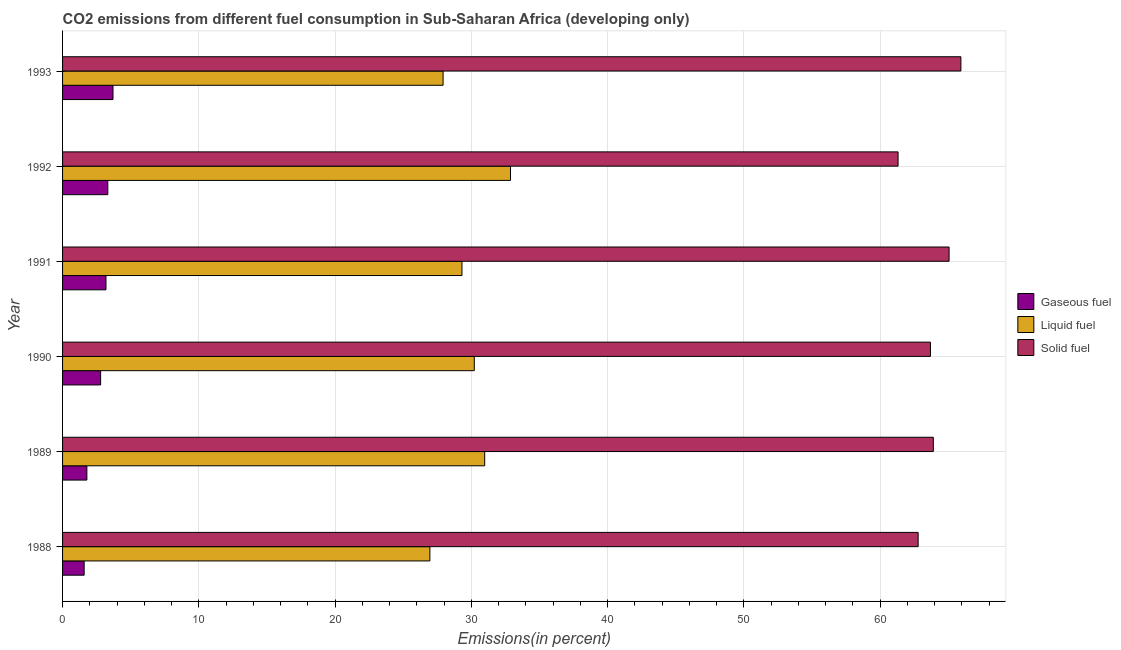How many different coloured bars are there?
Offer a terse response. 3. How many groups of bars are there?
Ensure brevity in your answer.  6. Are the number of bars per tick equal to the number of legend labels?
Your answer should be compact. Yes. How many bars are there on the 5th tick from the top?
Offer a terse response. 3. What is the label of the 6th group of bars from the top?
Offer a very short reply. 1988. In how many cases, is the number of bars for a given year not equal to the number of legend labels?
Provide a succinct answer. 0. What is the percentage of liquid fuel emission in 1992?
Make the answer very short. 32.87. Across all years, what is the maximum percentage of liquid fuel emission?
Your response must be concise. 32.87. Across all years, what is the minimum percentage of solid fuel emission?
Give a very brief answer. 61.31. In which year was the percentage of solid fuel emission maximum?
Make the answer very short. 1993. In which year was the percentage of solid fuel emission minimum?
Offer a terse response. 1992. What is the total percentage of liquid fuel emission in the graph?
Provide a succinct answer. 178.25. What is the difference between the percentage of gaseous fuel emission in 1989 and that in 1990?
Keep it short and to the point. -1.01. What is the difference between the percentage of liquid fuel emission in 1991 and the percentage of gaseous fuel emission in 1993?
Your answer should be compact. 25.61. What is the average percentage of liquid fuel emission per year?
Your answer should be compact. 29.71. In the year 1992, what is the difference between the percentage of solid fuel emission and percentage of liquid fuel emission?
Your answer should be compact. 28.44. In how many years, is the percentage of solid fuel emission greater than 38 %?
Make the answer very short. 6. What is the ratio of the percentage of gaseous fuel emission in 1990 to that in 1991?
Keep it short and to the point. 0.88. What is the difference between the highest and the second highest percentage of gaseous fuel emission?
Ensure brevity in your answer.  0.38. What is the difference between the highest and the lowest percentage of liquid fuel emission?
Your answer should be compact. 5.92. Is the sum of the percentage of liquid fuel emission in 1989 and 1993 greater than the maximum percentage of solid fuel emission across all years?
Give a very brief answer. No. What does the 2nd bar from the top in 1991 represents?
Give a very brief answer. Liquid fuel. What does the 2nd bar from the bottom in 1991 represents?
Provide a succinct answer. Liquid fuel. Is it the case that in every year, the sum of the percentage of gaseous fuel emission and percentage of liquid fuel emission is greater than the percentage of solid fuel emission?
Keep it short and to the point. No. Are all the bars in the graph horizontal?
Provide a short and direct response. Yes. What is the difference between two consecutive major ticks on the X-axis?
Provide a short and direct response. 10. Does the graph contain any zero values?
Make the answer very short. No. Does the graph contain grids?
Keep it short and to the point. Yes. Where does the legend appear in the graph?
Your answer should be very brief. Center right. How many legend labels are there?
Offer a terse response. 3. How are the legend labels stacked?
Your answer should be compact. Vertical. What is the title of the graph?
Ensure brevity in your answer.  CO2 emissions from different fuel consumption in Sub-Saharan Africa (developing only). What is the label or title of the X-axis?
Offer a very short reply. Emissions(in percent). What is the label or title of the Y-axis?
Provide a short and direct response. Year. What is the Emissions(in percent) of Gaseous fuel in 1988?
Offer a very short reply. 1.58. What is the Emissions(in percent) in Liquid fuel in 1988?
Give a very brief answer. 26.96. What is the Emissions(in percent) of Solid fuel in 1988?
Give a very brief answer. 62.78. What is the Emissions(in percent) of Gaseous fuel in 1989?
Ensure brevity in your answer.  1.78. What is the Emissions(in percent) in Liquid fuel in 1989?
Keep it short and to the point. 30.98. What is the Emissions(in percent) of Solid fuel in 1989?
Your response must be concise. 63.9. What is the Emissions(in percent) of Gaseous fuel in 1990?
Provide a short and direct response. 2.79. What is the Emissions(in percent) of Liquid fuel in 1990?
Offer a terse response. 30.21. What is the Emissions(in percent) in Solid fuel in 1990?
Keep it short and to the point. 63.69. What is the Emissions(in percent) of Gaseous fuel in 1991?
Give a very brief answer. 3.19. What is the Emissions(in percent) in Liquid fuel in 1991?
Offer a very short reply. 29.31. What is the Emissions(in percent) in Solid fuel in 1991?
Make the answer very short. 65.05. What is the Emissions(in percent) of Gaseous fuel in 1992?
Your answer should be very brief. 3.32. What is the Emissions(in percent) in Liquid fuel in 1992?
Your answer should be compact. 32.87. What is the Emissions(in percent) of Solid fuel in 1992?
Keep it short and to the point. 61.31. What is the Emissions(in percent) of Gaseous fuel in 1993?
Give a very brief answer. 3.7. What is the Emissions(in percent) of Liquid fuel in 1993?
Your answer should be very brief. 27.92. What is the Emissions(in percent) of Solid fuel in 1993?
Give a very brief answer. 65.92. Across all years, what is the maximum Emissions(in percent) of Gaseous fuel?
Ensure brevity in your answer.  3.7. Across all years, what is the maximum Emissions(in percent) of Liquid fuel?
Keep it short and to the point. 32.87. Across all years, what is the maximum Emissions(in percent) of Solid fuel?
Give a very brief answer. 65.92. Across all years, what is the minimum Emissions(in percent) in Gaseous fuel?
Your answer should be compact. 1.58. Across all years, what is the minimum Emissions(in percent) of Liquid fuel?
Your response must be concise. 26.96. Across all years, what is the minimum Emissions(in percent) in Solid fuel?
Your answer should be very brief. 61.31. What is the total Emissions(in percent) in Gaseous fuel in the graph?
Your answer should be compact. 16.37. What is the total Emissions(in percent) in Liquid fuel in the graph?
Provide a short and direct response. 178.25. What is the total Emissions(in percent) in Solid fuel in the graph?
Your answer should be very brief. 382.66. What is the difference between the Emissions(in percent) of Gaseous fuel in 1988 and that in 1989?
Provide a short and direct response. -0.2. What is the difference between the Emissions(in percent) in Liquid fuel in 1988 and that in 1989?
Give a very brief answer. -4.02. What is the difference between the Emissions(in percent) in Solid fuel in 1988 and that in 1989?
Make the answer very short. -1.11. What is the difference between the Emissions(in percent) in Gaseous fuel in 1988 and that in 1990?
Offer a terse response. -1.21. What is the difference between the Emissions(in percent) in Liquid fuel in 1988 and that in 1990?
Offer a very short reply. -3.26. What is the difference between the Emissions(in percent) in Solid fuel in 1988 and that in 1990?
Your response must be concise. -0.9. What is the difference between the Emissions(in percent) in Gaseous fuel in 1988 and that in 1991?
Your answer should be very brief. -1.6. What is the difference between the Emissions(in percent) in Liquid fuel in 1988 and that in 1991?
Provide a short and direct response. -2.35. What is the difference between the Emissions(in percent) in Solid fuel in 1988 and that in 1991?
Offer a terse response. -2.27. What is the difference between the Emissions(in percent) of Gaseous fuel in 1988 and that in 1992?
Offer a terse response. -1.74. What is the difference between the Emissions(in percent) in Liquid fuel in 1988 and that in 1992?
Offer a terse response. -5.92. What is the difference between the Emissions(in percent) in Solid fuel in 1988 and that in 1992?
Your answer should be compact. 1.47. What is the difference between the Emissions(in percent) of Gaseous fuel in 1988 and that in 1993?
Your answer should be very brief. -2.12. What is the difference between the Emissions(in percent) of Liquid fuel in 1988 and that in 1993?
Keep it short and to the point. -0.97. What is the difference between the Emissions(in percent) in Solid fuel in 1988 and that in 1993?
Provide a succinct answer. -3.14. What is the difference between the Emissions(in percent) of Gaseous fuel in 1989 and that in 1990?
Offer a terse response. -1.01. What is the difference between the Emissions(in percent) in Liquid fuel in 1989 and that in 1990?
Your answer should be compact. 0.76. What is the difference between the Emissions(in percent) in Solid fuel in 1989 and that in 1990?
Offer a very short reply. 0.21. What is the difference between the Emissions(in percent) in Gaseous fuel in 1989 and that in 1991?
Give a very brief answer. -1.4. What is the difference between the Emissions(in percent) in Liquid fuel in 1989 and that in 1991?
Offer a terse response. 1.67. What is the difference between the Emissions(in percent) in Solid fuel in 1989 and that in 1991?
Provide a short and direct response. -1.16. What is the difference between the Emissions(in percent) in Gaseous fuel in 1989 and that in 1992?
Offer a very short reply. -1.54. What is the difference between the Emissions(in percent) in Liquid fuel in 1989 and that in 1992?
Your answer should be very brief. -1.89. What is the difference between the Emissions(in percent) in Solid fuel in 1989 and that in 1992?
Make the answer very short. 2.59. What is the difference between the Emissions(in percent) in Gaseous fuel in 1989 and that in 1993?
Keep it short and to the point. -1.92. What is the difference between the Emissions(in percent) of Liquid fuel in 1989 and that in 1993?
Make the answer very short. 3.05. What is the difference between the Emissions(in percent) of Solid fuel in 1989 and that in 1993?
Provide a succinct answer. -2.02. What is the difference between the Emissions(in percent) of Gaseous fuel in 1990 and that in 1991?
Provide a short and direct response. -0.39. What is the difference between the Emissions(in percent) in Liquid fuel in 1990 and that in 1991?
Your answer should be compact. 0.9. What is the difference between the Emissions(in percent) of Solid fuel in 1990 and that in 1991?
Offer a very short reply. -1.37. What is the difference between the Emissions(in percent) of Gaseous fuel in 1990 and that in 1992?
Make the answer very short. -0.53. What is the difference between the Emissions(in percent) of Liquid fuel in 1990 and that in 1992?
Provide a succinct answer. -2.66. What is the difference between the Emissions(in percent) of Solid fuel in 1990 and that in 1992?
Offer a very short reply. 2.38. What is the difference between the Emissions(in percent) in Gaseous fuel in 1990 and that in 1993?
Offer a very short reply. -0.91. What is the difference between the Emissions(in percent) in Liquid fuel in 1990 and that in 1993?
Keep it short and to the point. 2.29. What is the difference between the Emissions(in percent) of Solid fuel in 1990 and that in 1993?
Offer a terse response. -2.23. What is the difference between the Emissions(in percent) in Gaseous fuel in 1991 and that in 1992?
Give a very brief answer. -0.13. What is the difference between the Emissions(in percent) of Liquid fuel in 1991 and that in 1992?
Provide a short and direct response. -3.56. What is the difference between the Emissions(in percent) in Solid fuel in 1991 and that in 1992?
Give a very brief answer. 3.74. What is the difference between the Emissions(in percent) of Gaseous fuel in 1991 and that in 1993?
Your response must be concise. -0.51. What is the difference between the Emissions(in percent) of Liquid fuel in 1991 and that in 1993?
Provide a succinct answer. 1.39. What is the difference between the Emissions(in percent) of Solid fuel in 1991 and that in 1993?
Provide a succinct answer. -0.87. What is the difference between the Emissions(in percent) of Gaseous fuel in 1992 and that in 1993?
Offer a very short reply. -0.38. What is the difference between the Emissions(in percent) in Liquid fuel in 1992 and that in 1993?
Your answer should be compact. 4.95. What is the difference between the Emissions(in percent) in Solid fuel in 1992 and that in 1993?
Give a very brief answer. -4.61. What is the difference between the Emissions(in percent) in Gaseous fuel in 1988 and the Emissions(in percent) in Liquid fuel in 1989?
Make the answer very short. -29.39. What is the difference between the Emissions(in percent) in Gaseous fuel in 1988 and the Emissions(in percent) in Solid fuel in 1989?
Your response must be concise. -62.32. What is the difference between the Emissions(in percent) of Liquid fuel in 1988 and the Emissions(in percent) of Solid fuel in 1989?
Your answer should be very brief. -36.94. What is the difference between the Emissions(in percent) of Gaseous fuel in 1988 and the Emissions(in percent) of Liquid fuel in 1990?
Keep it short and to the point. -28.63. What is the difference between the Emissions(in percent) of Gaseous fuel in 1988 and the Emissions(in percent) of Solid fuel in 1990?
Provide a short and direct response. -62.1. What is the difference between the Emissions(in percent) in Liquid fuel in 1988 and the Emissions(in percent) in Solid fuel in 1990?
Make the answer very short. -36.73. What is the difference between the Emissions(in percent) in Gaseous fuel in 1988 and the Emissions(in percent) in Liquid fuel in 1991?
Keep it short and to the point. -27.73. What is the difference between the Emissions(in percent) of Gaseous fuel in 1988 and the Emissions(in percent) of Solid fuel in 1991?
Give a very brief answer. -63.47. What is the difference between the Emissions(in percent) in Liquid fuel in 1988 and the Emissions(in percent) in Solid fuel in 1991?
Make the answer very short. -38.1. What is the difference between the Emissions(in percent) in Gaseous fuel in 1988 and the Emissions(in percent) in Liquid fuel in 1992?
Your response must be concise. -31.29. What is the difference between the Emissions(in percent) of Gaseous fuel in 1988 and the Emissions(in percent) of Solid fuel in 1992?
Offer a terse response. -59.73. What is the difference between the Emissions(in percent) in Liquid fuel in 1988 and the Emissions(in percent) in Solid fuel in 1992?
Provide a succinct answer. -34.36. What is the difference between the Emissions(in percent) of Gaseous fuel in 1988 and the Emissions(in percent) of Liquid fuel in 1993?
Offer a very short reply. -26.34. What is the difference between the Emissions(in percent) of Gaseous fuel in 1988 and the Emissions(in percent) of Solid fuel in 1993?
Give a very brief answer. -64.34. What is the difference between the Emissions(in percent) of Liquid fuel in 1988 and the Emissions(in percent) of Solid fuel in 1993?
Keep it short and to the point. -38.97. What is the difference between the Emissions(in percent) in Gaseous fuel in 1989 and the Emissions(in percent) in Liquid fuel in 1990?
Keep it short and to the point. -28.43. What is the difference between the Emissions(in percent) in Gaseous fuel in 1989 and the Emissions(in percent) in Solid fuel in 1990?
Provide a short and direct response. -61.91. What is the difference between the Emissions(in percent) in Liquid fuel in 1989 and the Emissions(in percent) in Solid fuel in 1990?
Ensure brevity in your answer.  -32.71. What is the difference between the Emissions(in percent) of Gaseous fuel in 1989 and the Emissions(in percent) of Liquid fuel in 1991?
Your answer should be compact. -27.53. What is the difference between the Emissions(in percent) of Gaseous fuel in 1989 and the Emissions(in percent) of Solid fuel in 1991?
Ensure brevity in your answer.  -63.27. What is the difference between the Emissions(in percent) in Liquid fuel in 1989 and the Emissions(in percent) in Solid fuel in 1991?
Keep it short and to the point. -34.08. What is the difference between the Emissions(in percent) in Gaseous fuel in 1989 and the Emissions(in percent) in Liquid fuel in 1992?
Make the answer very short. -31.09. What is the difference between the Emissions(in percent) of Gaseous fuel in 1989 and the Emissions(in percent) of Solid fuel in 1992?
Make the answer very short. -59.53. What is the difference between the Emissions(in percent) of Liquid fuel in 1989 and the Emissions(in percent) of Solid fuel in 1992?
Your answer should be compact. -30.33. What is the difference between the Emissions(in percent) of Gaseous fuel in 1989 and the Emissions(in percent) of Liquid fuel in 1993?
Your response must be concise. -26.14. What is the difference between the Emissions(in percent) of Gaseous fuel in 1989 and the Emissions(in percent) of Solid fuel in 1993?
Your answer should be very brief. -64.14. What is the difference between the Emissions(in percent) of Liquid fuel in 1989 and the Emissions(in percent) of Solid fuel in 1993?
Offer a terse response. -34.95. What is the difference between the Emissions(in percent) in Gaseous fuel in 1990 and the Emissions(in percent) in Liquid fuel in 1991?
Offer a terse response. -26.52. What is the difference between the Emissions(in percent) of Gaseous fuel in 1990 and the Emissions(in percent) of Solid fuel in 1991?
Provide a short and direct response. -62.26. What is the difference between the Emissions(in percent) in Liquid fuel in 1990 and the Emissions(in percent) in Solid fuel in 1991?
Provide a succinct answer. -34.84. What is the difference between the Emissions(in percent) of Gaseous fuel in 1990 and the Emissions(in percent) of Liquid fuel in 1992?
Your answer should be compact. -30.08. What is the difference between the Emissions(in percent) in Gaseous fuel in 1990 and the Emissions(in percent) in Solid fuel in 1992?
Keep it short and to the point. -58.52. What is the difference between the Emissions(in percent) of Liquid fuel in 1990 and the Emissions(in percent) of Solid fuel in 1992?
Offer a terse response. -31.1. What is the difference between the Emissions(in percent) of Gaseous fuel in 1990 and the Emissions(in percent) of Liquid fuel in 1993?
Keep it short and to the point. -25.13. What is the difference between the Emissions(in percent) of Gaseous fuel in 1990 and the Emissions(in percent) of Solid fuel in 1993?
Provide a short and direct response. -63.13. What is the difference between the Emissions(in percent) in Liquid fuel in 1990 and the Emissions(in percent) in Solid fuel in 1993?
Offer a very short reply. -35.71. What is the difference between the Emissions(in percent) in Gaseous fuel in 1991 and the Emissions(in percent) in Liquid fuel in 1992?
Provide a short and direct response. -29.68. What is the difference between the Emissions(in percent) in Gaseous fuel in 1991 and the Emissions(in percent) in Solid fuel in 1992?
Give a very brief answer. -58.13. What is the difference between the Emissions(in percent) of Liquid fuel in 1991 and the Emissions(in percent) of Solid fuel in 1992?
Keep it short and to the point. -32. What is the difference between the Emissions(in percent) of Gaseous fuel in 1991 and the Emissions(in percent) of Liquid fuel in 1993?
Keep it short and to the point. -24.74. What is the difference between the Emissions(in percent) of Gaseous fuel in 1991 and the Emissions(in percent) of Solid fuel in 1993?
Your answer should be very brief. -62.74. What is the difference between the Emissions(in percent) of Liquid fuel in 1991 and the Emissions(in percent) of Solid fuel in 1993?
Offer a very short reply. -36.61. What is the difference between the Emissions(in percent) in Gaseous fuel in 1992 and the Emissions(in percent) in Liquid fuel in 1993?
Offer a very short reply. -24.6. What is the difference between the Emissions(in percent) in Gaseous fuel in 1992 and the Emissions(in percent) in Solid fuel in 1993?
Ensure brevity in your answer.  -62.6. What is the difference between the Emissions(in percent) of Liquid fuel in 1992 and the Emissions(in percent) of Solid fuel in 1993?
Your answer should be compact. -33.05. What is the average Emissions(in percent) in Gaseous fuel per year?
Your response must be concise. 2.73. What is the average Emissions(in percent) in Liquid fuel per year?
Ensure brevity in your answer.  29.71. What is the average Emissions(in percent) of Solid fuel per year?
Offer a very short reply. 63.78. In the year 1988, what is the difference between the Emissions(in percent) of Gaseous fuel and Emissions(in percent) of Liquid fuel?
Make the answer very short. -25.37. In the year 1988, what is the difference between the Emissions(in percent) in Gaseous fuel and Emissions(in percent) in Solid fuel?
Your answer should be compact. -61.2. In the year 1988, what is the difference between the Emissions(in percent) of Liquid fuel and Emissions(in percent) of Solid fuel?
Your answer should be very brief. -35.83. In the year 1989, what is the difference between the Emissions(in percent) in Gaseous fuel and Emissions(in percent) in Liquid fuel?
Provide a succinct answer. -29.19. In the year 1989, what is the difference between the Emissions(in percent) in Gaseous fuel and Emissions(in percent) in Solid fuel?
Offer a terse response. -62.12. In the year 1989, what is the difference between the Emissions(in percent) in Liquid fuel and Emissions(in percent) in Solid fuel?
Provide a succinct answer. -32.92. In the year 1990, what is the difference between the Emissions(in percent) in Gaseous fuel and Emissions(in percent) in Liquid fuel?
Your answer should be very brief. -27.42. In the year 1990, what is the difference between the Emissions(in percent) of Gaseous fuel and Emissions(in percent) of Solid fuel?
Your answer should be very brief. -60.9. In the year 1990, what is the difference between the Emissions(in percent) of Liquid fuel and Emissions(in percent) of Solid fuel?
Keep it short and to the point. -33.47. In the year 1991, what is the difference between the Emissions(in percent) in Gaseous fuel and Emissions(in percent) in Liquid fuel?
Offer a terse response. -26.12. In the year 1991, what is the difference between the Emissions(in percent) in Gaseous fuel and Emissions(in percent) in Solid fuel?
Make the answer very short. -61.87. In the year 1991, what is the difference between the Emissions(in percent) of Liquid fuel and Emissions(in percent) of Solid fuel?
Your response must be concise. -35.75. In the year 1992, what is the difference between the Emissions(in percent) of Gaseous fuel and Emissions(in percent) of Liquid fuel?
Offer a terse response. -29.55. In the year 1992, what is the difference between the Emissions(in percent) in Gaseous fuel and Emissions(in percent) in Solid fuel?
Provide a succinct answer. -57.99. In the year 1992, what is the difference between the Emissions(in percent) of Liquid fuel and Emissions(in percent) of Solid fuel?
Give a very brief answer. -28.44. In the year 1993, what is the difference between the Emissions(in percent) in Gaseous fuel and Emissions(in percent) in Liquid fuel?
Your answer should be very brief. -24.22. In the year 1993, what is the difference between the Emissions(in percent) in Gaseous fuel and Emissions(in percent) in Solid fuel?
Give a very brief answer. -62.22. In the year 1993, what is the difference between the Emissions(in percent) in Liquid fuel and Emissions(in percent) in Solid fuel?
Provide a short and direct response. -38. What is the ratio of the Emissions(in percent) of Gaseous fuel in 1988 to that in 1989?
Offer a very short reply. 0.89. What is the ratio of the Emissions(in percent) of Liquid fuel in 1988 to that in 1989?
Your answer should be very brief. 0.87. What is the ratio of the Emissions(in percent) in Solid fuel in 1988 to that in 1989?
Provide a short and direct response. 0.98. What is the ratio of the Emissions(in percent) of Gaseous fuel in 1988 to that in 1990?
Offer a terse response. 0.57. What is the ratio of the Emissions(in percent) in Liquid fuel in 1988 to that in 1990?
Give a very brief answer. 0.89. What is the ratio of the Emissions(in percent) in Solid fuel in 1988 to that in 1990?
Your answer should be compact. 0.99. What is the ratio of the Emissions(in percent) in Gaseous fuel in 1988 to that in 1991?
Ensure brevity in your answer.  0.5. What is the ratio of the Emissions(in percent) of Liquid fuel in 1988 to that in 1991?
Your response must be concise. 0.92. What is the ratio of the Emissions(in percent) in Solid fuel in 1988 to that in 1991?
Your answer should be compact. 0.97. What is the ratio of the Emissions(in percent) of Gaseous fuel in 1988 to that in 1992?
Your answer should be compact. 0.48. What is the ratio of the Emissions(in percent) in Liquid fuel in 1988 to that in 1992?
Give a very brief answer. 0.82. What is the ratio of the Emissions(in percent) in Gaseous fuel in 1988 to that in 1993?
Offer a terse response. 0.43. What is the ratio of the Emissions(in percent) in Liquid fuel in 1988 to that in 1993?
Keep it short and to the point. 0.97. What is the ratio of the Emissions(in percent) in Gaseous fuel in 1989 to that in 1990?
Your answer should be compact. 0.64. What is the ratio of the Emissions(in percent) in Liquid fuel in 1989 to that in 1990?
Ensure brevity in your answer.  1.03. What is the ratio of the Emissions(in percent) in Solid fuel in 1989 to that in 1990?
Offer a very short reply. 1. What is the ratio of the Emissions(in percent) of Gaseous fuel in 1989 to that in 1991?
Your answer should be very brief. 0.56. What is the ratio of the Emissions(in percent) of Liquid fuel in 1989 to that in 1991?
Offer a very short reply. 1.06. What is the ratio of the Emissions(in percent) in Solid fuel in 1989 to that in 1991?
Your answer should be very brief. 0.98. What is the ratio of the Emissions(in percent) of Gaseous fuel in 1989 to that in 1992?
Give a very brief answer. 0.54. What is the ratio of the Emissions(in percent) in Liquid fuel in 1989 to that in 1992?
Your answer should be very brief. 0.94. What is the ratio of the Emissions(in percent) in Solid fuel in 1989 to that in 1992?
Your response must be concise. 1.04. What is the ratio of the Emissions(in percent) in Gaseous fuel in 1989 to that in 1993?
Keep it short and to the point. 0.48. What is the ratio of the Emissions(in percent) of Liquid fuel in 1989 to that in 1993?
Keep it short and to the point. 1.11. What is the ratio of the Emissions(in percent) in Solid fuel in 1989 to that in 1993?
Make the answer very short. 0.97. What is the ratio of the Emissions(in percent) in Gaseous fuel in 1990 to that in 1991?
Ensure brevity in your answer.  0.88. What is the ratio of the Emissions(in percent) in Liquid fuel in 1990 to that in 1991?
Your response must be concise. 1.03. What is the ratio of the Emissions(in percent) of Solid fuel in 1990 to that in 1991?
Your answer should be compact. 0.98. What is the ratio of the Emissions(in percent) in Gaseous fuel in 1990 to that in 1992?
Your response must be concise. 0.84. What is the ratio of the Emissions(in percent) in Liquid fuel in 1990 to that in 1992?
Your response must be concise. 0.92. What is the ratio of the Emissions(in percent) in Solid fuel in 1990 to that in 1992?
Give a very brief answer. 1.04. What is the ratio of the Emissions(in percent) in Gaseous fuel in 1990 to that in 1993?
Give a very brief answer. 0.75. What is the ratio of the Emissions(in percent) of Liquid fuel in 1990 to that in 1993?
Your answer should be very brief. 1.08. What is the ratio of the Emissions(in percent) in Solid fuel in 1990 to that in 1993?
Give a very brief answer. 0.97. What is the ratio of the Emissions(in percent) in Gaseous fuel in 1991 to that in 1992?
Offer a very short reply. 0.96. What is the ratio of the Emissions(in percent) of Liquid fuel in 1991 to that in 1992?
Offer a terse response. 0.89. What is the ratio of the Emissions(in percent) in Solid fuel in 1991 to that in 1992?
Your answer should be compact. 1.06. What is the ratio of the Emissions(in percent) of Gaseous fuel in 1991 to that in 1993?
Your answer should be compact. 0.86. What is the ratio of the Emissions(in percent) in Liquid fuel in 1991 to that in 1993?
Provide a succinct answer. 1.05. What is the ratio of the Emissions(in percent) in Solid fuel in 1991 to that in 1993?
Offer a terse response. 0.99. What is the ratio of the Emissions(in percent) in Gaseous fuel in 1992 to that in 1993?
Give a very brief answer. 0.9. What is the ratio of the Emissions(in percent) in Liquid fuel in 1992 to that in 1993?
Your response must be concise. 1.18. What is the ratio of the Emissions(in percent) of Solid fuel in 1992 to that in 1993?
Ensure brevity in your answer.  0.93. What is the difference between the highest and the second highest Emissions(in percent) of Gaseous fuel?
Provide a short and direct response. 0.38. What is the difference between the highest and the second highest Emissions(in percent) in Liquid fuel?
Offer a terse response. 1.89. What is the difference between the highest and the second highest Emissions(in percent) in Solid fuel?
Give a very brief answer. 0.87. What is the difference between the highest and the lowest Emissions(in percent) of Gaseous fuel?
Provide a short and direct response. 2.12. What is the difference between the highest and the lowest Emissions(in percent) in Liquid fuel?
Your answer should be very brief. 5.92. What is the difference between the highest and the lowest Emissions(in percent) in Solid fuel?
Make the answer very short. 4.61. 